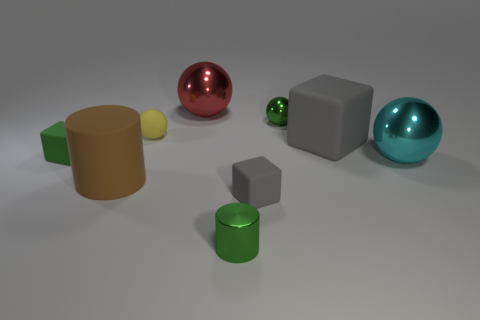Is there a small metallic ball that has the same color as the tiny cylinder?
Keep it short and to the point. Yes. Is the color of the tiny metallic thing in front of the large gray cube the same as the small shiny sphere?
Provide a succinct answer. Yes. What is the shape of the matte object that is the same color as the metallic cylinder?
Give a very brief answer. Cube. Is the color of the small metallic cylinder the same as the tiny metallic sphere?
Keep it short and to the point. Yes. There is a rubber object that is behind the cyan object and on the right side of the yellow matte ball; what color is it?
Your response must be concise. Gray. There is a gray matte thing behind the big brown matte cylinder that is to the left of the small green shiny ball; are there any large gray matte cubes that are behind it?
Provide a succinct answer. No. What number of objects are large green metallic cylinders or matte cylinders?
Offer a very short reply. 1. Do the large gray object and the large thing behind the yellow object have the same material?
Offer a terse response. No. Is there any other thing that has the same color as the large cylinder?
Provide a short and direct response. No. What number of things are large objects left of the tiny green shiny ball or green metal things that are in front of the big cyan sphere?
Offer a terse response. 3. 